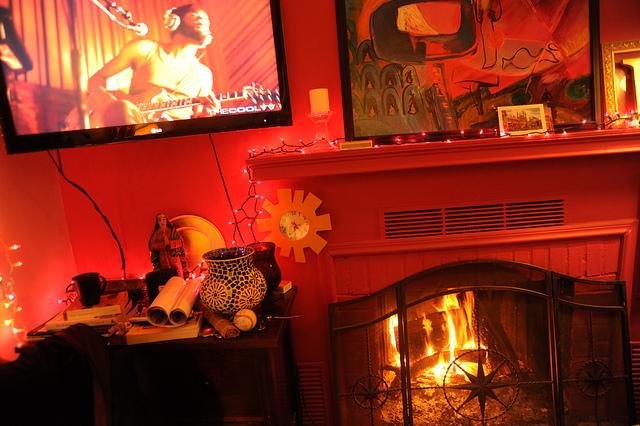What instrument is the man on TV playing?
Write a very short answer. Guitar. Are there Christmas lights on the fireplace?
Concise answer only. Yes. Is there a fire in the fireplace?
Concise answer only. Yes. 